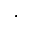<formula> <loc_0><loc_0><loc_500><loc_500>^ { \cdot }</formula> 